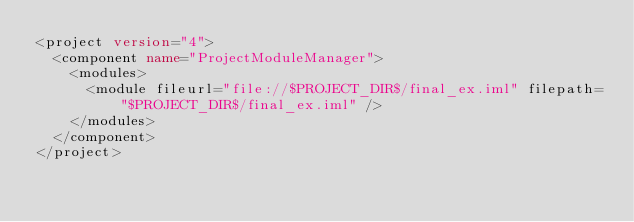<code> <loc_0><loc_0><loc_500><loc_500><_XML_><project version="4">
  <component name="ProjectModuleManager">
    <modules>
      <module fileurl="file://$PROJECT_DIR$/final_ex.iml" filepath="$PROJECT_DIR$/final_ex.iml" />
    </modules>
  </component>
</project></code> 